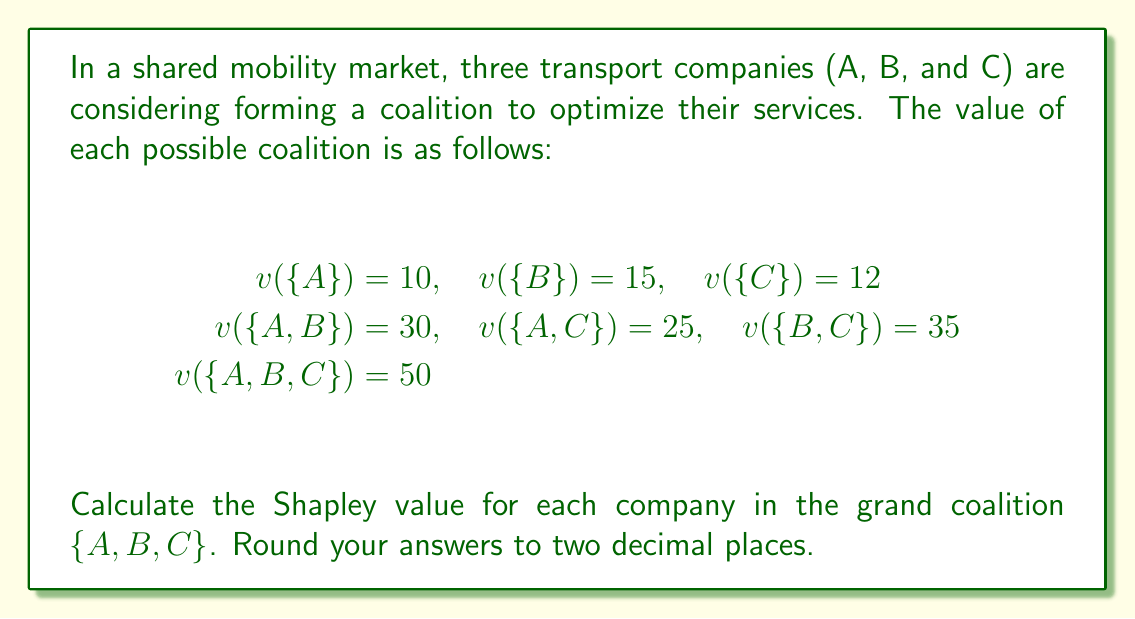Give your solution to this math problem. To calculate the Shapley value for each player (company), we need to determine their marginal contributions to all possible coalition formations. The Shapley value for player $i$ is given by:

$$\phi_i(v) = \sum_{S \subseteq N \setminus \{i\}} \frac{|S|!(n-|S|-1)!}{n!}[v(S \cup \{i\}) - v(S)]$$

Where $N$ is the set of all players, $n$ is the total number of players, and $S$ is a subset of $N$ not containing player $i$.

Let's calculate the Shapley value for each company:

1. For Company A:
   $\phi_A(v) = \frac{1}{3}[v(\{A\}) - v(\{\})] + \frac{1}{6}[v(\{A,B\}) - v(\{B\})] + \frac{1}{6}[v(\{A,C\}) - v(\{C\})] + \frac{1}{3}[v(\{A,B,C\}) - v(\{B,C\})]$
   $= \frac{1}{3}(10 - 0) + \frac{1}{6}(30 - 15) + \frac{1}{6}(25 - 12) + \frac{1}{3}(50 - 35)$
   $= \frac{10}{3} + \frac{15}{6} + \frac{13}{6} + \frac{15}{3} = 3.33 + 2.5 + 2.17 + 5 = 13$

2. For Company B:
   $\phi_B(v) = \frac{1}{3}[v(\{B\}) - v(\{\})] + \frac{1}{6}[v(\{A,B\}) - v(\{A\})] + \frac{1}{6}[v(\{B,C\}) - v(\{C\})] + \frac{1}{3}[v(\{A,B,C\}) - v(\{A,C\})]$
   $= \frac{1}{3}(15 - 0) + \frac{1}{6}(30 - 10) + \frac{1}{6}(35 - 12) + \frac{1}{3}(50 - 25)$
   $= 5 + \frac{20}{6} + \frac{23}{6} + \frac{25}{3} = 5 + 3.33 + 3.83 + 8.33 = 20.49$

3. For Company C:
   $\phi_C(v) = \frac{1}{3}[v(\{C\}) - v(\{\})] + \frac{1}{6}[v(\{A,C\}) - v(\{A\})] + \frac{1}{6}[v(\{B,C\}) - v(\{B\})] + \frac{1}{3}[v(\{A,B,C\}) - v(\{A,B\})]$
   $= \frac{1}{3}(12 - 0) + \frac{1}{6}(25 - 10) + \frac{1}{6}(35 - 15) + \frac{1}{3}(50 - 30)$
   $= 4 + \frac{15}{6} + \frac{20}{6} + \frac{20}{3} = 4 + 2.5 + 3.33 + 6.67 = 16.5$

Rounding to two decimal places, we get the Shapley values for each company.
Answer: The Shapley values for each company in the grand coalition are:
Company A: $13.00
Company B: $20.49
Company C: $16.50 